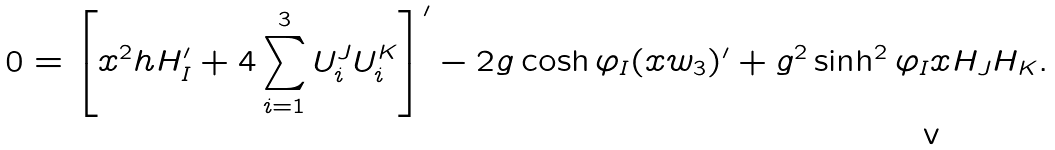Convert formula to latex. <formula><loc_0><loc_0><loc_500><loc_500>0 = \left [ x ^ { 2 } h H _ { I } ^ { \prime } + 4 \sum _ { i = 1 } ^ { 3 } U _ { i } ^ { J } U _ { i } ^ { K } \right ] ^ { \prime } - 2 g \cosh \varphi _ { I } ( x w _ { 3 } ) ^ { \prime } + g ^ { 2 } \sinh ^ { 2 } \varphi _ { I } x H _ { J } H _ { K } .</formula> 